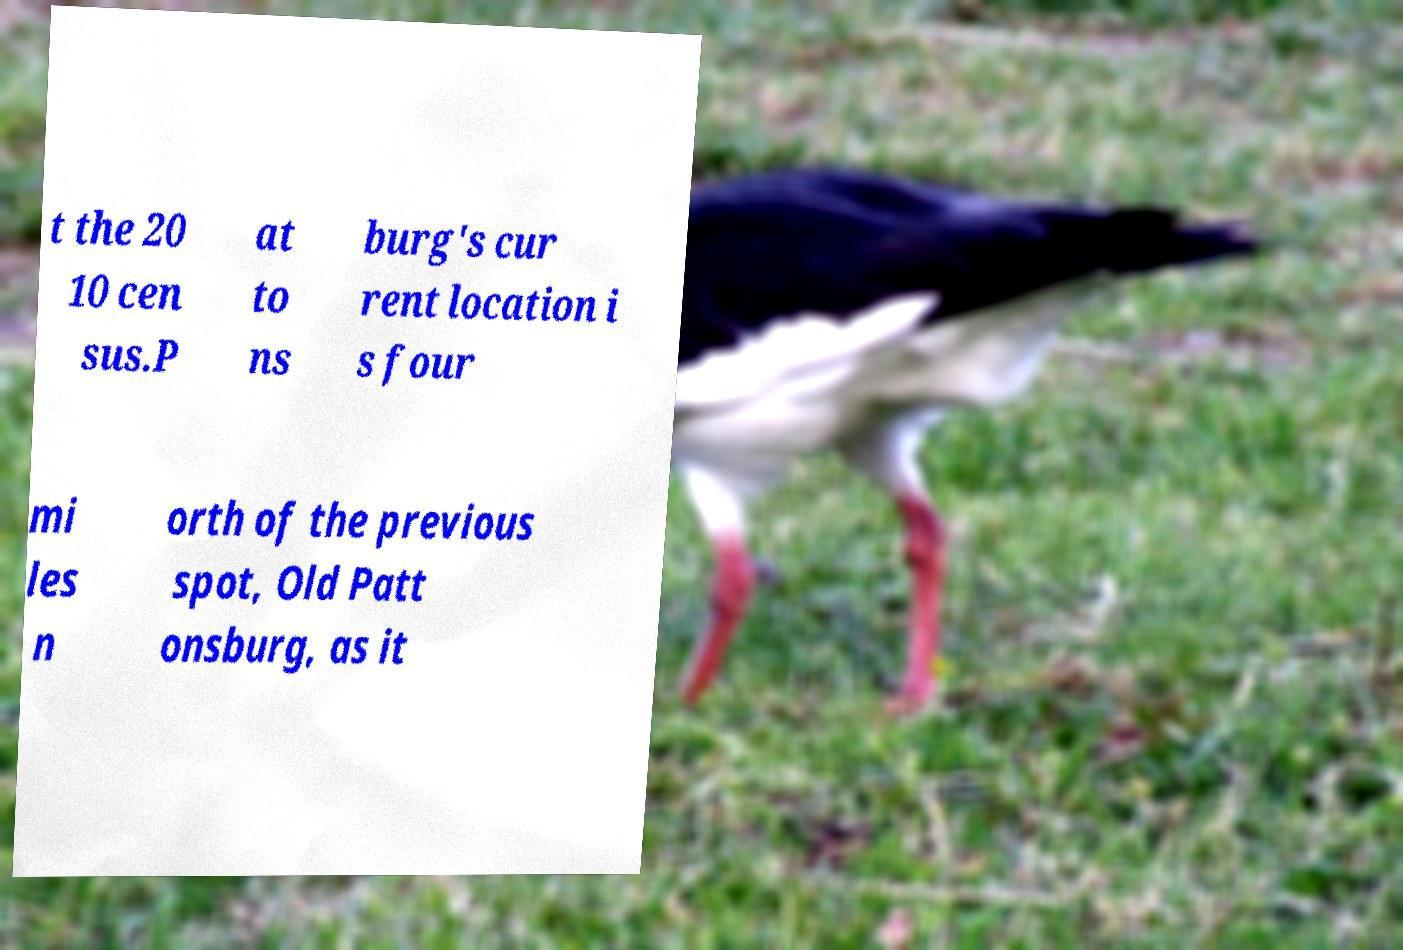Could you extract and type out the text from this image? t the 20 10 cen sus.P at to ns burg's cur rent location i s four mi les n orth of the previous spot, Old Patt onsburg, as it 